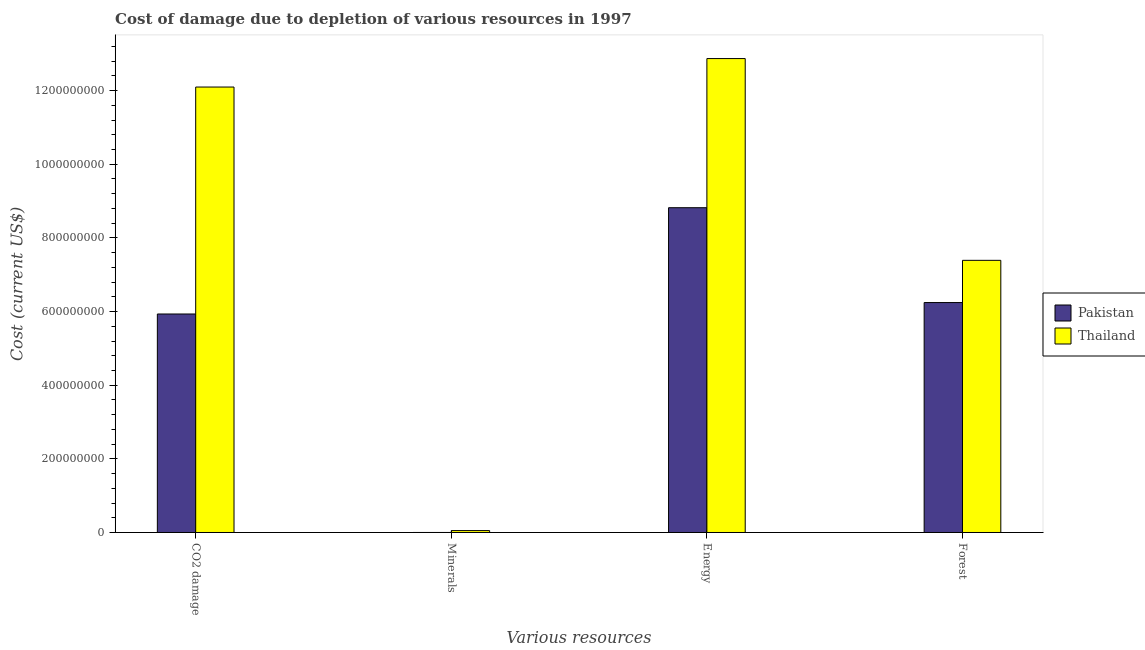How many different coloured bars are there?
Ensure brevity in your answer.  2. How many groups of bars are there?
Offer a very short reply. 4. How many bars are there on the 2nd tick from the left?
Your response must be concise. 2. What is the label of the 2nd group of bars from the left?
Give a very brief answer. Minerals. What is the cost of damage due to depletion of minerals in Pakistan?
Give a very brief answer. 3.32e+04. Across all countries, what is the maximum cost of damage due to depletion of energy?
Your answer should be very brief. 1.29e+09. Across all countries, what is the minimum cost of damage due to depletion of energy?
Make the answer very short. 8.82e+08. In which country was the cost of damage due to depletion of forests maximum?
Provide a short and direct response. Thailand. What is the total cost of damage due to depletion of energy in the graph?
Your response must be concise. 2.17e+09. What is the difference between the cost of damage due to depletion of energy in Thailand and that in Pakistan?
Your answer should be compact. 4.05e+08. What is the difference between the cost of damage due to depletion of energy in Pakistan and the cost of damage due to depletion of coal in Thailand?
Your answer should be compact. -3.28e+08. What is the average cost of damage due to depletion of forests per country?
Your response must be concise. 6.82e+08. What is the difference between the cost of damage due to depletion of energy and cost of damage due to depletion of coal in Pakistan?
Offer a terse response. 2.89e+08. In how many countries, is the cost of damage due to depletion of minerals greater than 760000000 US$?
Your response must be concise. 0. What is the ratio of the cost of damage due to depletion of coal in Thailand to that in Pakistan?
Give a very brief answer. 2.04. Is the difference between the cost of damage due to depletion of coal in Pakistan and Thailand greater than the difference between the cost of damage due to depletion of energy in Pakistan and Thailand?
Provide a succinct answer. No. What is the difference between the highest and the second highest cost of damage due to depletion of minerals?
Offer a terse response. 5.12e+06. What is the difference between the highest and the lowest cost of damage due to depletion of energy?
Ensure brevity in your answer.  4.05e+08. What does the 2nd bar from the left in CO2 damage represents?
Offer a very short reply. Thailand. What does the 2nd bar from the right in CO2 damage represents?
Offer a very short reply. Pakistan. How many bars are there?
Provide a short and direct response. 8. Are all the bars in the graph horizontal?
Your response must be concise. No. Are the values on the major ticks of Y-axis written in scientific E-notation?
Offer a very short reply. No. Does the graph contain any zero values?
Offer a terse response. No. How many legend labels are there?
Make the answer very short. 2. What is the title of the graph?
Provide a succinct answer. Cost of damage due to depletion of various resources in 1997 . Does "OECD members" appear as one of the legend labels in the graph?
Make the answer very short. No. What is the label or title of the X-axis?
Offer a very short reply. Various resources. What is the label or title of the Y-axis?
Offer a very short reply. Cost (current US$). What is the Cost (current US$) of Pakistan in CO2 damage?
Provide a succinct answer. 5.93e+08. What is the Cost (current US$) of Thailand in CO2 damage?
Offer a terse response. 1.21e+09. What is the Cost (current US$) of Pakistan in Minerals?
Offer a terse response. 3.32e+04. What is the Cost (current US$) in Thailand in Minerals?
Offer a very short reply. 5.15e+06. What is the Cost (current US$) in Pakistan in Energy?
Your answer should be compact. 8.82e+08. What is the Cost (current US$) in Thailand in Energy?
Your answer should be compact. 1.29e+09. What is the Cost (current US$) of Pakistan in Forest?
Offer a very short reply. 6.24e+08. What is the Cost (current US$) in Thailand in Forest?
Your response must be concise. 7.39e+08. Across all Various resources, what is the maximum Cost (current US$) of Pakistan?
Provide a short and direct response. 8.82e+08. Across all Various resources, what is the maximum Cost (current US$) in Thailand?
Offer a terse response. 1.29e+09. Across all Various resources, what is the minimum Cost (current US$) in Pakistan?
Offer a very short reply. 3.32e+04. Across all Various resources, what is the minimum Cost (current US$) in Thailand?
Provide a short and direct response. 5.15e+06. What is the total Cost (current US$) of Pakistan in the graph?
Offer a very short reply. 2.10e+09. What is the total Cost (current US$) of Thailand in the graph?
Keep it short and to the point. 3.24e+09. What is the difference between the Cost (current US$) in Pakistan in CO2 damage and that in Minerals?
Provide a succinct answer. 5.93e+08. What is the difference between the Cost (current US$) in Thailand in CO2 damage and that in Minerals?
Provide a succinct answer. 1.20e+09. What is the difference between the Cost (current US$) of Pakistan in CO2 damage and that in Energy?
Offer a very short reply. -2.89e+08. What is the difference between the Cost (current US$) of Thailand in CO2 damage and that in Energy?
Your response must be concise. -7.73e+07. What is the difference between the Cost (current US$) of Pakistan in CO2 damage and that in Forest?
Give a very brief answer. -3.11e+07. What is the difference between the Cost (current US$) in Thailand in CO2 damage and that in Forest?
Your answer should be very brief. 4.71e+08. What is the difference between the Cost (current US$) in Pakistan in Minerals and that in Energy?
Offer a very short reply. -8.82e+08. What is the difference between the Cost (current US$) in Thailand in Minerals and that in Energy?
Your answer should be very brief. -1.28e+09. What is the difference between the Cost (current US$) in Pakistan in Minerals and that in Forest?
Make the answer very short. -6.24e+08. What is the difference between the Cost (current US$) in Thailand in Minerals and that in Forest?
Keep it short and to the point. -7.34e+08. What is the difference between the Cost (current US$) of Pakistan in Energy and that in Forest?
Make the answer very short. 2.58e+08. What is the difference between the Cost (current US$) in Thailand in Energy and that in Forest?
Make the answer very short. 5.48e+08. What is the difference between the Cost (current US$) of Pakistan in CO2 damage and the Cost (current US$) of Thailand in Minerals?
Your answer should be compact. 5.88e+08. What is the difference between the Cost (current US$) of Pakistan in CO2 damage and the Cost (current US$) of Thailand in Energy?
Ensure brevity in your answer.  -6.94e+08. What is the difference between the Cost (current US$) of Pakistan in CO2 damage and the Cost (current US$) of Thailand in Forest?
Give a very brief answer. -1.46e+08. What is the difference between the Cost (current US$) of Pakistan in Minerals and the Cost (current US$) of Thailand in Energy?
Ensure brevity in your answer.  -1.29e+09. What is the difference between the Cost (current US$) of Pakistan in Minerals and the Cost (current US$) of Thailand in Forest?
Provide a succinct answer. -7.39e+08. What is the difference between the Cost (current US$) of Pakistan in Energy and the Cost (current US$) of Thailand in Forest?
Offer a very short reply. 1.43e+08. What is the average Cost (current US$) of Pakistan per Various resources?
Your answer should be compact. 5.25e+08. What is the average Cost (current US$) in Thailand per Various resources?
Ensure brevity in your answer.  8.10e+08. What is the difference between the Cost (current US$) in Pakistan and Cost (current US$) in Thailand in CO2 damage?
Offer a terse response. -6.16e+08. What is the difference between the Cost (current US$) in Pakistan and Cost (current US$) in Thailand in Minerals?
Keep it short and to the point. -5.12e+06. What is the difference between the Cost (current US$) in Pakistan and Cost (current US$) in Thailand in Energy?
Give a very brief answer. -4.05e+08. What is the difference between the Cost (current US$) of Pakistan and Cost (current US$) of Thailand in Forest?
Ensure brevity in your answer.  -1.15e+08. What is the ratio of the Cost (current US$) of Pakistan in CO2 damage to that in Minerals?
Offer a terse response. 1.79e+04. What is the ratio of the Cost (current US$) in Thailand in CO2 damage to that in Minerals?
Your answer should be very brief. 234.72. What is the ratio of the Cost (current US$) in Pakistan in CO2 damage to that in Energy?
Your answer should be compact. 0.67. What is the ratio of the Cost (current US$) of Thailand in CO2 damage to that in Energy?
Offer a very short reply. 0.94. What is the ratio of the Cost (current US$) in Pakistan in CO2 damage to that in Forest?
Make the answer very short. 0.95. What is the ratio of the Cost (current US$) in Thailand in CO2 damage to that in Forest?
Keep it short and to the point. 1.64. What is the ratio of the Cost (current US$) of Pakistan in Minerals to that in Energy?
Provide a short and direct response. 0. What is the ratio of the Cost (current US$) of Thailand in Minerals to that in Energy?
Offer a terse response. 0. What is the ratio of the Cost (current US$) in Thailand in Minerals to that in Forest?
Provide a succinct answer. 0.01. What is the ratio of the Cost (current US$) in Pakistan in Energy to that in Forest?
Make the answer very short. 1.41. What is the ratio of the Cost (current US$) of Thailand in Energy to that in Forest?
Give a very brief answer. 1.74. What is the difference between the highest and the second highest Cost (current US$) in Pakistan?
Your answer should be very brief. 2.58e+08. What is the difference between the highest and the second highest Cost (current US$) of Thailand?
Provide a short and direct response. 7.73e+07. What is the difference between the highest and the lowest Cost (current US$) of Pakistan?
Give a very brief answer. 8.82e+08. What is the difference between the highest and the lowest Cost (current US$) of Thailand?
Your answer should be compact. 1.28e+09. 